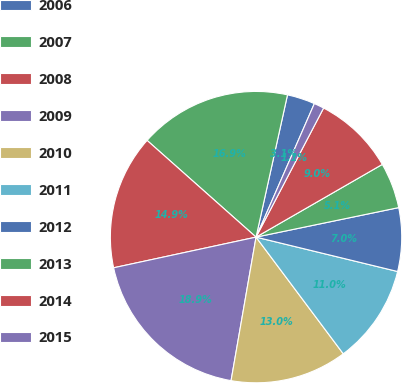Convert chart to OTSL. <chart><loc_0><loc_0><loc_500><loc_500><pie_chart><fcel>2006<fcel>2007<fcel>2008<fcel>2009<fcel>2010<fcel>2011<fcel>2012<fcel>2013<fcel>2014<fcel>2015<nl><fcel>3.09%<fcel>16.91%<fcel>14.93%<fcel>18.88%<fcel>12.96%<fcel>10.99%<fcel>7.04%<fcel>5.07%<fcel>9.01%<fcel>1.12%<nl></chart> 